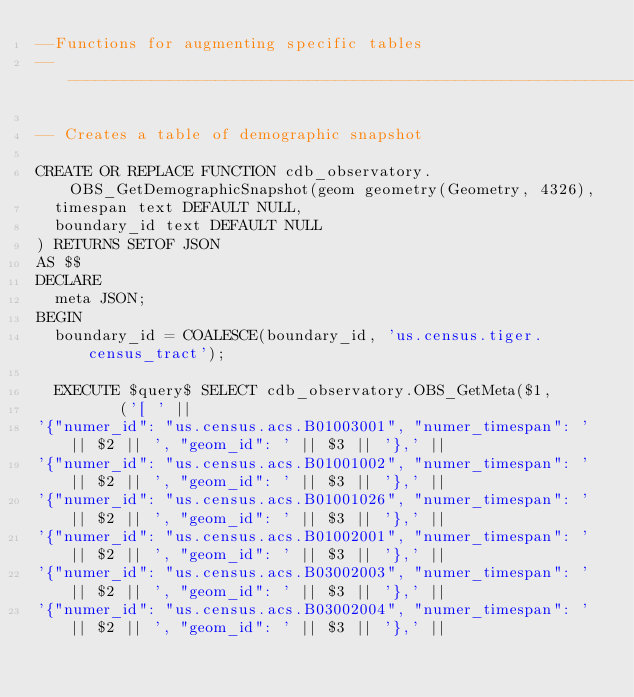<code> <loc_0><loc_0><loc_500><loc_500><_SQL_>--Functions for augmenting specific tables
--------------------------------------------------------------------------------

-- Creates a table of demographic snapshot

CREATE OR REPLACE FUNCTION cdb_observatory.OBS_GetDemographicSnapshot(geom geometry(Geometry, 4326),
  timespan text DEFAULT NULL,
  boundary_id text DEFAULT NULL
) RETURNS SETOF JSON
AS $$
DECLARE
  meta JSON;
BEGIN
  boundary_id = COALESCE(boundary_id, 'us.census.tiger.census_tract');

  EXECUTE $query$ SELECT cdb_observatory.OBS_GetMeta($1,
         ('[ ' ||
'{"numer_id": "us.census.acs.B01003001", "numer_timespan": ' || $2 || ', "geom_id": ' || $3 || '},' ||
'{"numer_id": "us.census.acs.B01001002", "numer_timespan": ' || $2 || ', "geom_id": ' || $3 || '},' ||
'{"numer_id": "us.census.acs.B01001026", "numer_timespan": ' || $2 || ', "geom_id": ' || $3 || '},' ||
'{"numer_id": "us.census.acs.B01002001", "numer_timespan": ' || $2 || ', "geom_id": ' || $3 || '},' ||
'{"numer_id": "us.census.acs.B03002003", "numer_timespan": ' || $2 || ', "geom_id": ' || $3 || '},' ||
'{"numer_id": "us.census.acs.B03002004", "numer_timespan": ' || $2 || ', "geom_id": ' || $3 || '},' ||</code> 